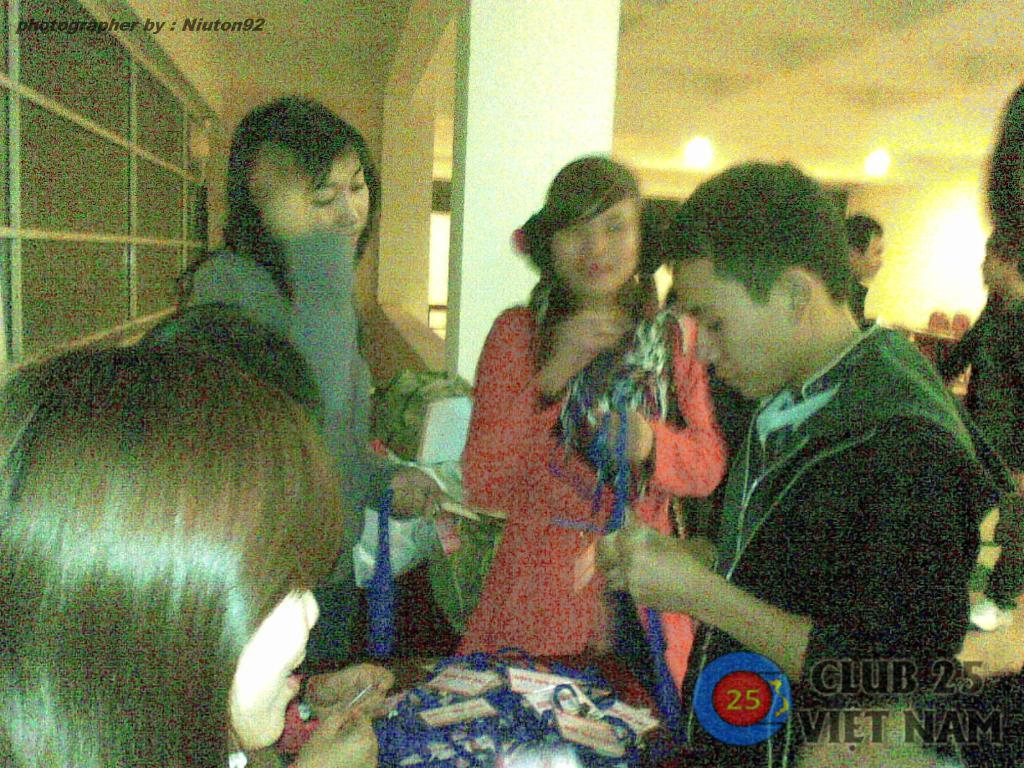What is the main subject of the image? The main subject of the image is a group of people in the middle of the image. What else can be seen in the image besides the group of people? There is text in the top left hand side of the image and a logo in the bottom right hand side of the image. How much salt is present in the image? There is no salt present in the image. What division is being represented in the image? The image does not depict any division; it features a group of people, text, and a logo. 